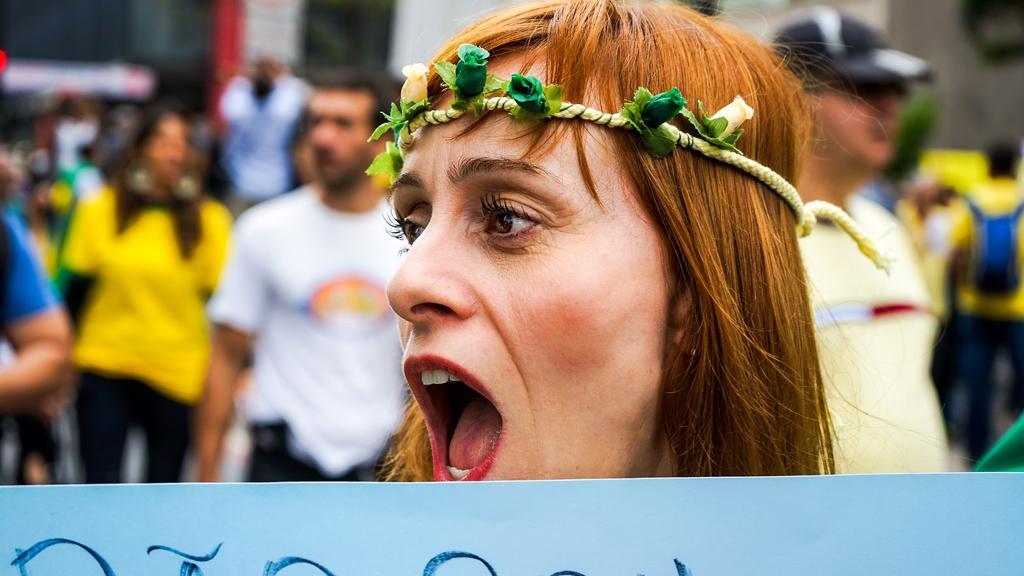Describe this image in one or two sentences. In the middle of the picture, we see a girl wearing floral crown and she is trying to talk something. At the bottom of the picture, we see a blue board with text written on it. Behind her, we see people walking on the road. In the background, we see buildings. It is blurred in the background. 